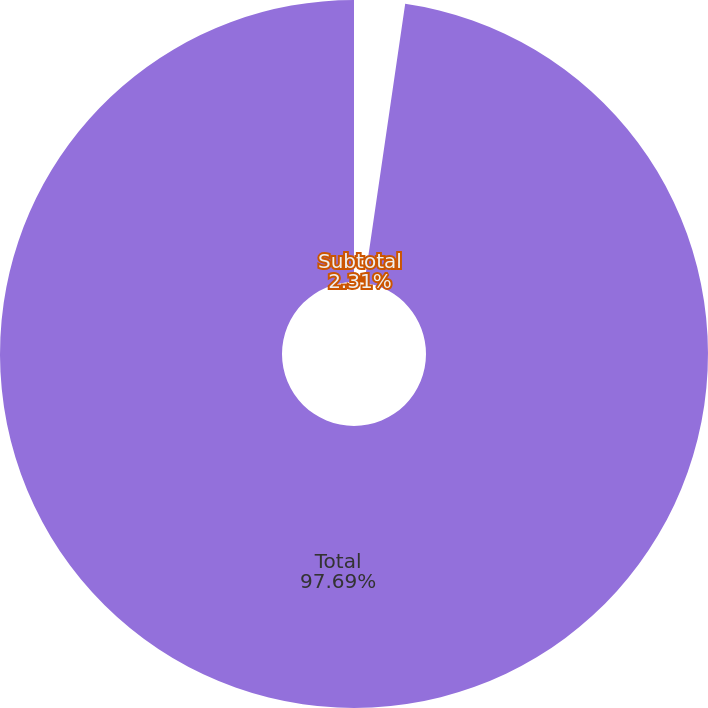Convert chart. <chart><loc_0><loc_0><loc_500><loc_500><pie_chart><fcel>Subtotal<fcel>Total<nl><fcel>2.31%<fcel>97.69%<nl></chart> 